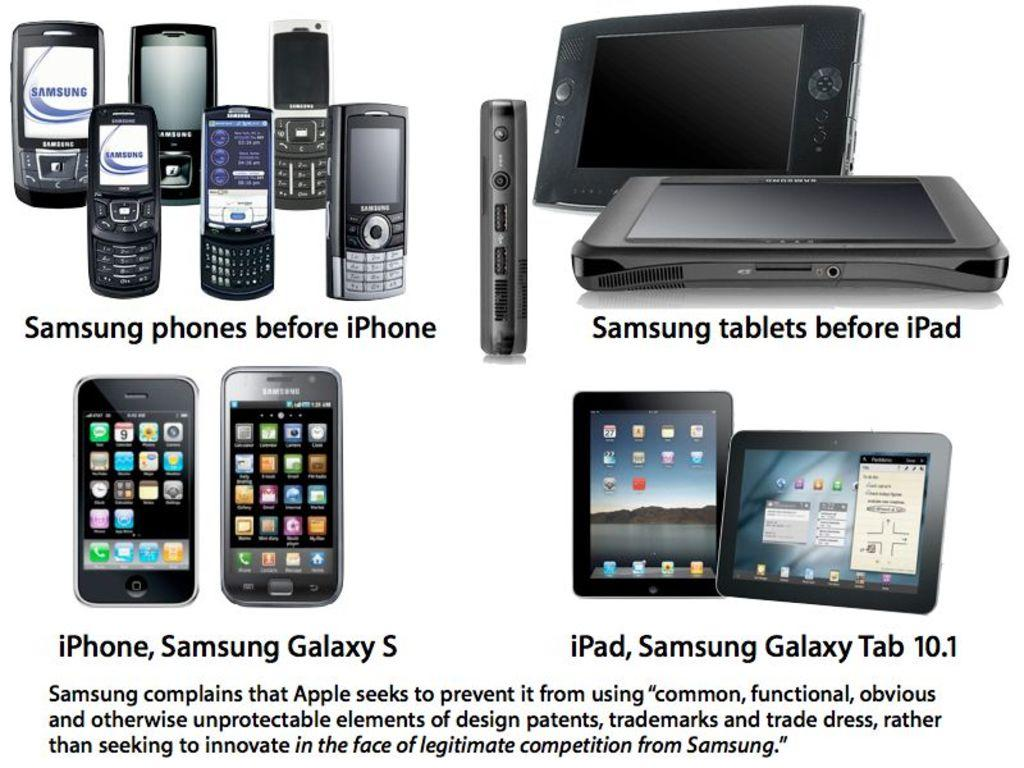<image>
Create a compact narrative representing the image presented. An advert for Samsun phones and tablets professing their superiority over Apple products. 